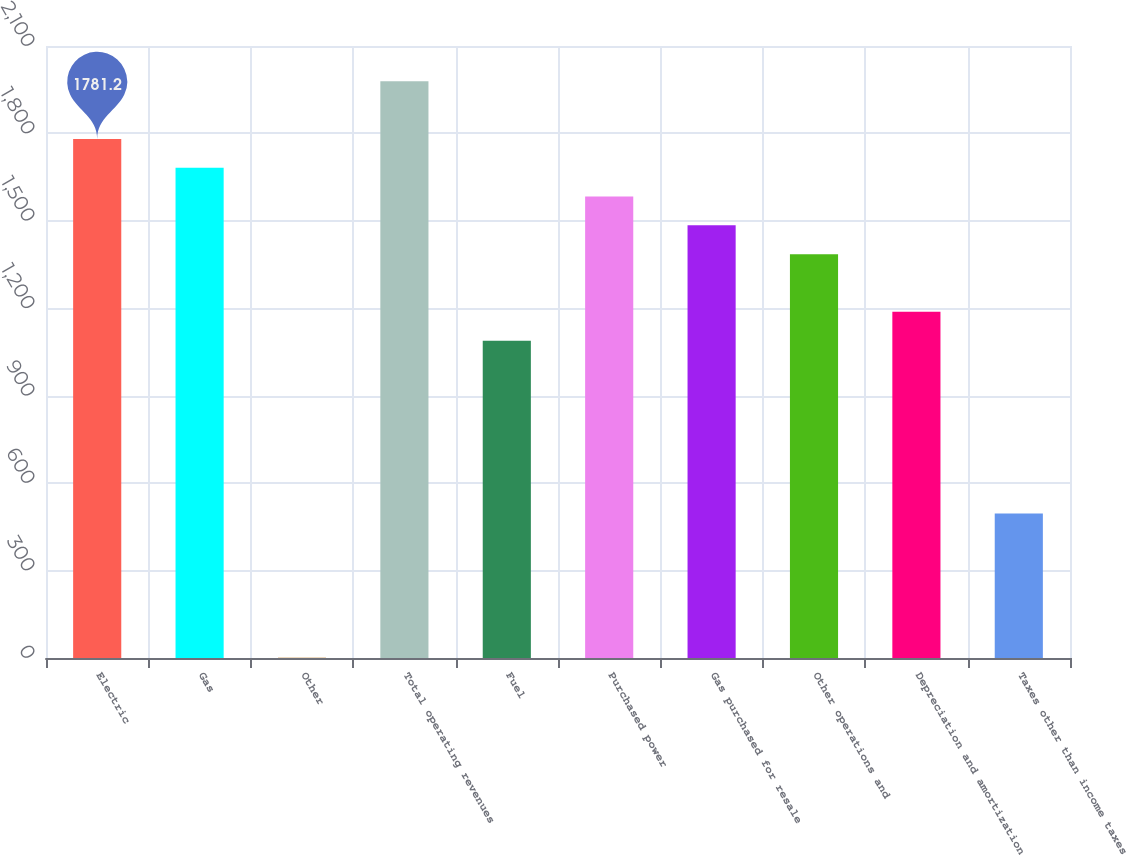<chart> <loc_0><loc_0><loc_500><loc_500><bar_chart><fcel>Electric<fcel>Gas<fcel>Other<fcel>Total operating revenues<fcel>Fuel<fcel>Purchased power<fcel>Gas purchased for resale<fcel>Other operations and<fcel>Depreciation and amortization<fcel>Taxes other than income taxes<nl><fcel>1781.2<fcel>1682.3<fcel>1<fcel>1979<fcel>1088.9<fcel>1583.4<fcel>1484.5<fcel>1385.6<fcel>1187.8<fcel>495.5<nl></chart> 